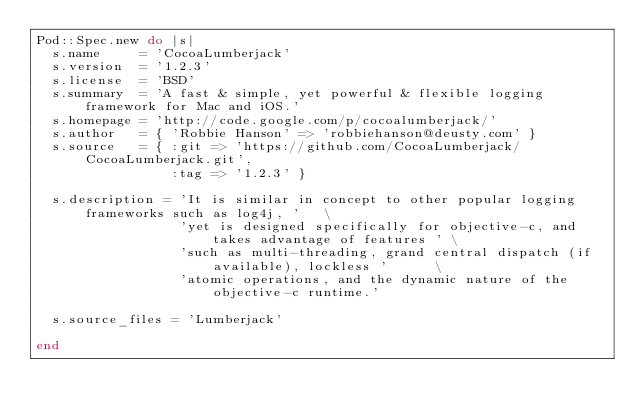<code> <loc_0><loc_0><loc_500><loc_500><_Ruby_>Pod::Spec.new do |s|
  s.name     = 'CocoaLumberjack'
  s.version  = '1.2.3'
  s.license  = 'BSD'
  s.summary  = 'A fast & simple, yet powerful & flexible logging framework for Mac and iOS.'
  s.homepage = 'http://code.google.com/p/cocoalumberjack/'
  s.author   = { 'Robbie Hanson' => 'robbiehanson@deusty.com' }
  s.source   = { :git => 'https://github.com/CocoaLumberjack/CocoaLumberjack.git',
                 :tag => '1.2.3' }

  s.description = 'It is similar in concept to other popular logging frameworks such as log4j, '   \
                  'yet is designed specifically for objective-c, and takes advantage of features ' \
                  'such as multi-threading, grand central dispatch (if available), lockless '      \
                  'atomic operations, and the dynamic nature of the objective-c runtime.'

  s.source_files = 'Lumberjack'

end
</code> 